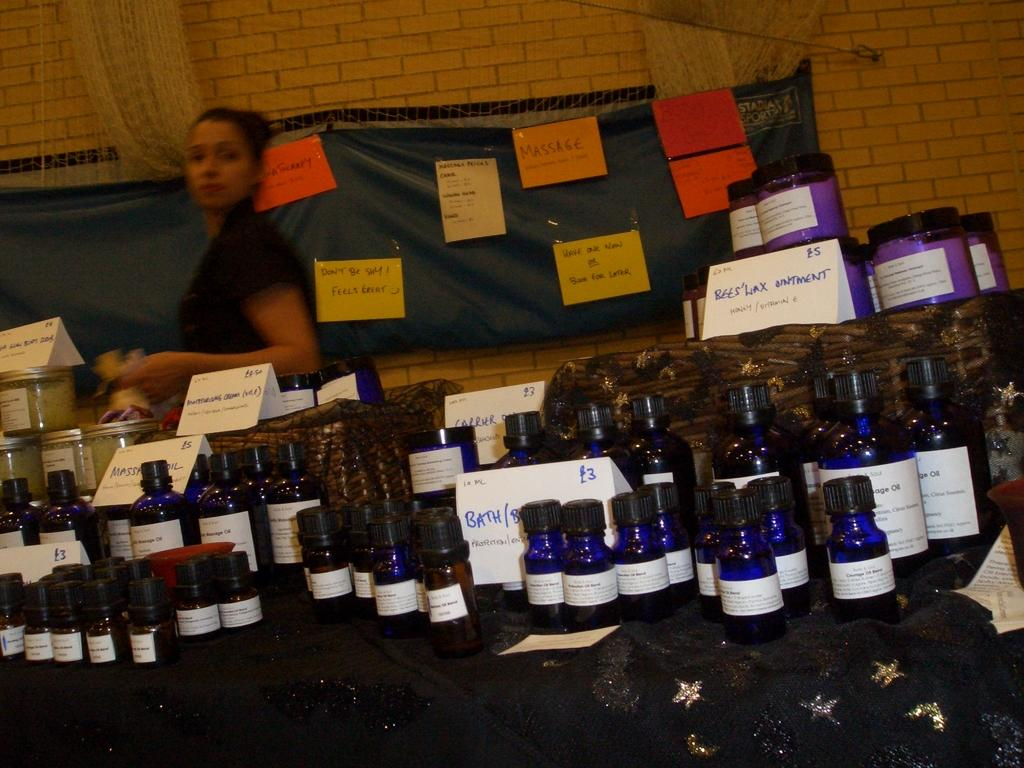What can be seen on the table in the image? There are many bottles on the table with labels. Can you describe the person in the image? There is a woman standing in the image. What is written on the wall in the image? There are posts with messages on the wall. What type of force can be seen affecting the dust particles in the image? There is no mention of dust particles or any force affecting them in the image. 